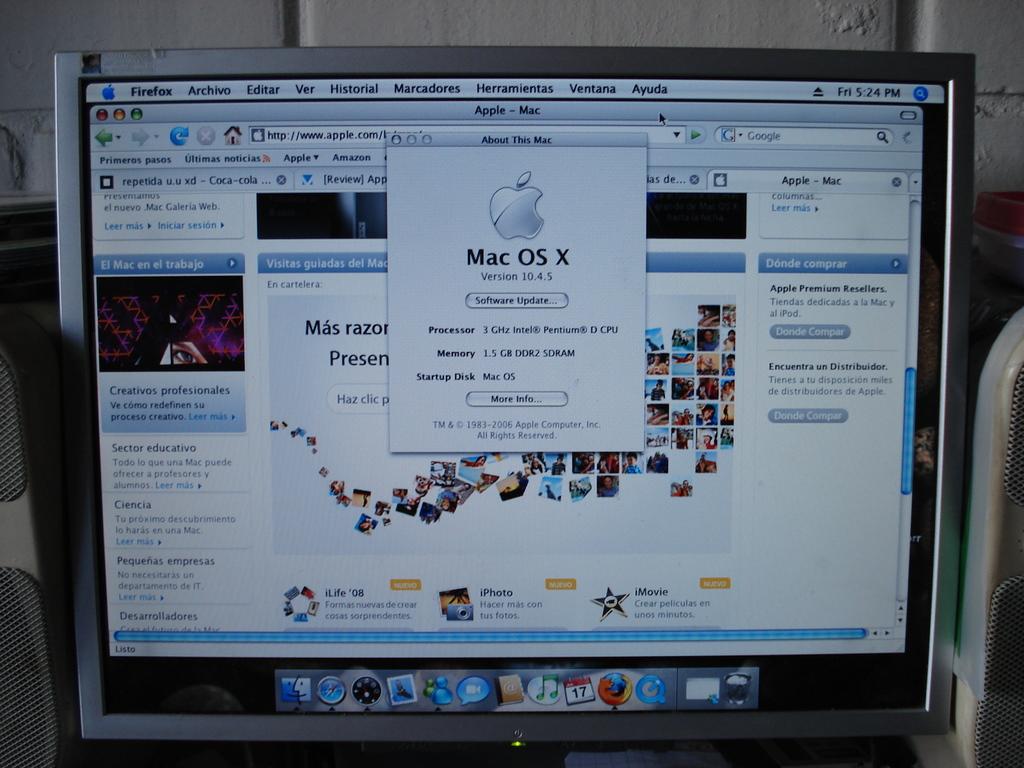What is the operating system?
Provide a succinct answer. Mac os x. 